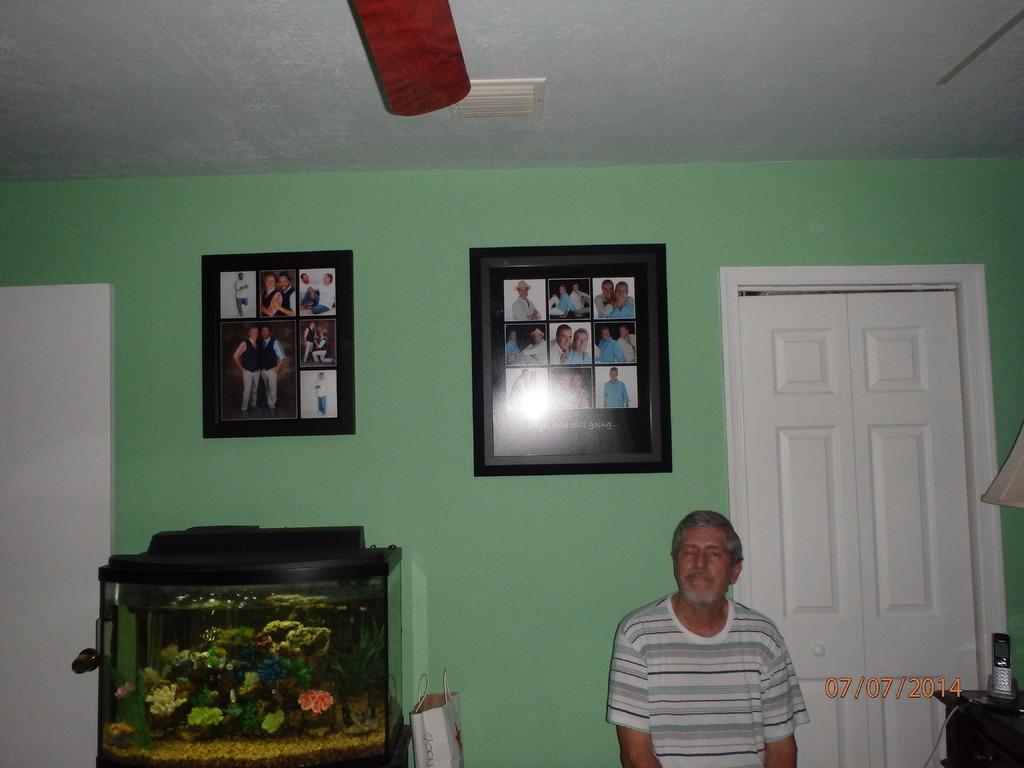Can you describe this image briefly? In this image I can see a man. The man is wearing a t-shirt. Here I can see a wall, on the wall I can see photos attached to it. Here I can see an aquarium and a bag. On the right side I can see a white color door and other objects. Here I can see a watermark. 